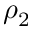Convert formula to latex. <formula><loc_0><loc_0><loc_500><loc_500>\rho _ { 2 }</formula> 